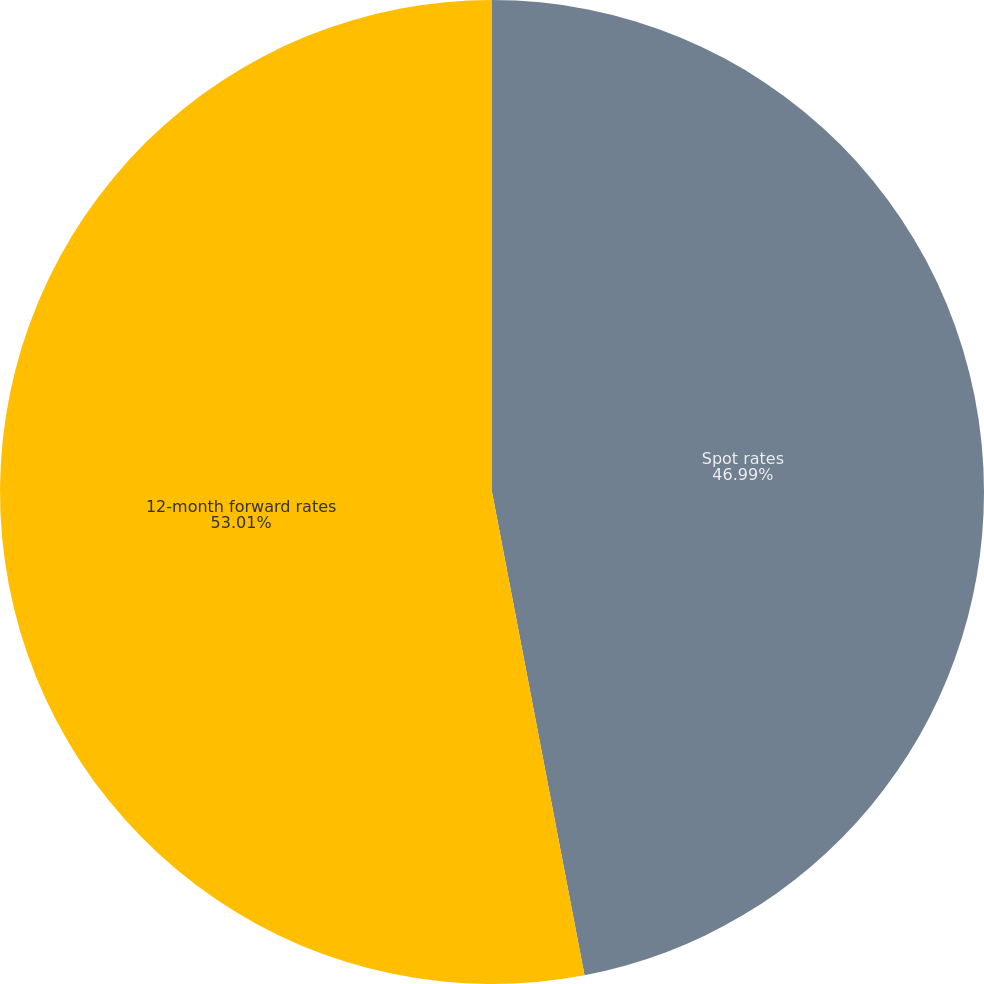Convert chart to OTSL. <chart><loc_0><loc_0><loc_500><loc_500><pie_chart><fcel>Spot rates<fcel>12-month forward rates<nl><fcel>46.99%<fcel>53.01%<nl></chart> 